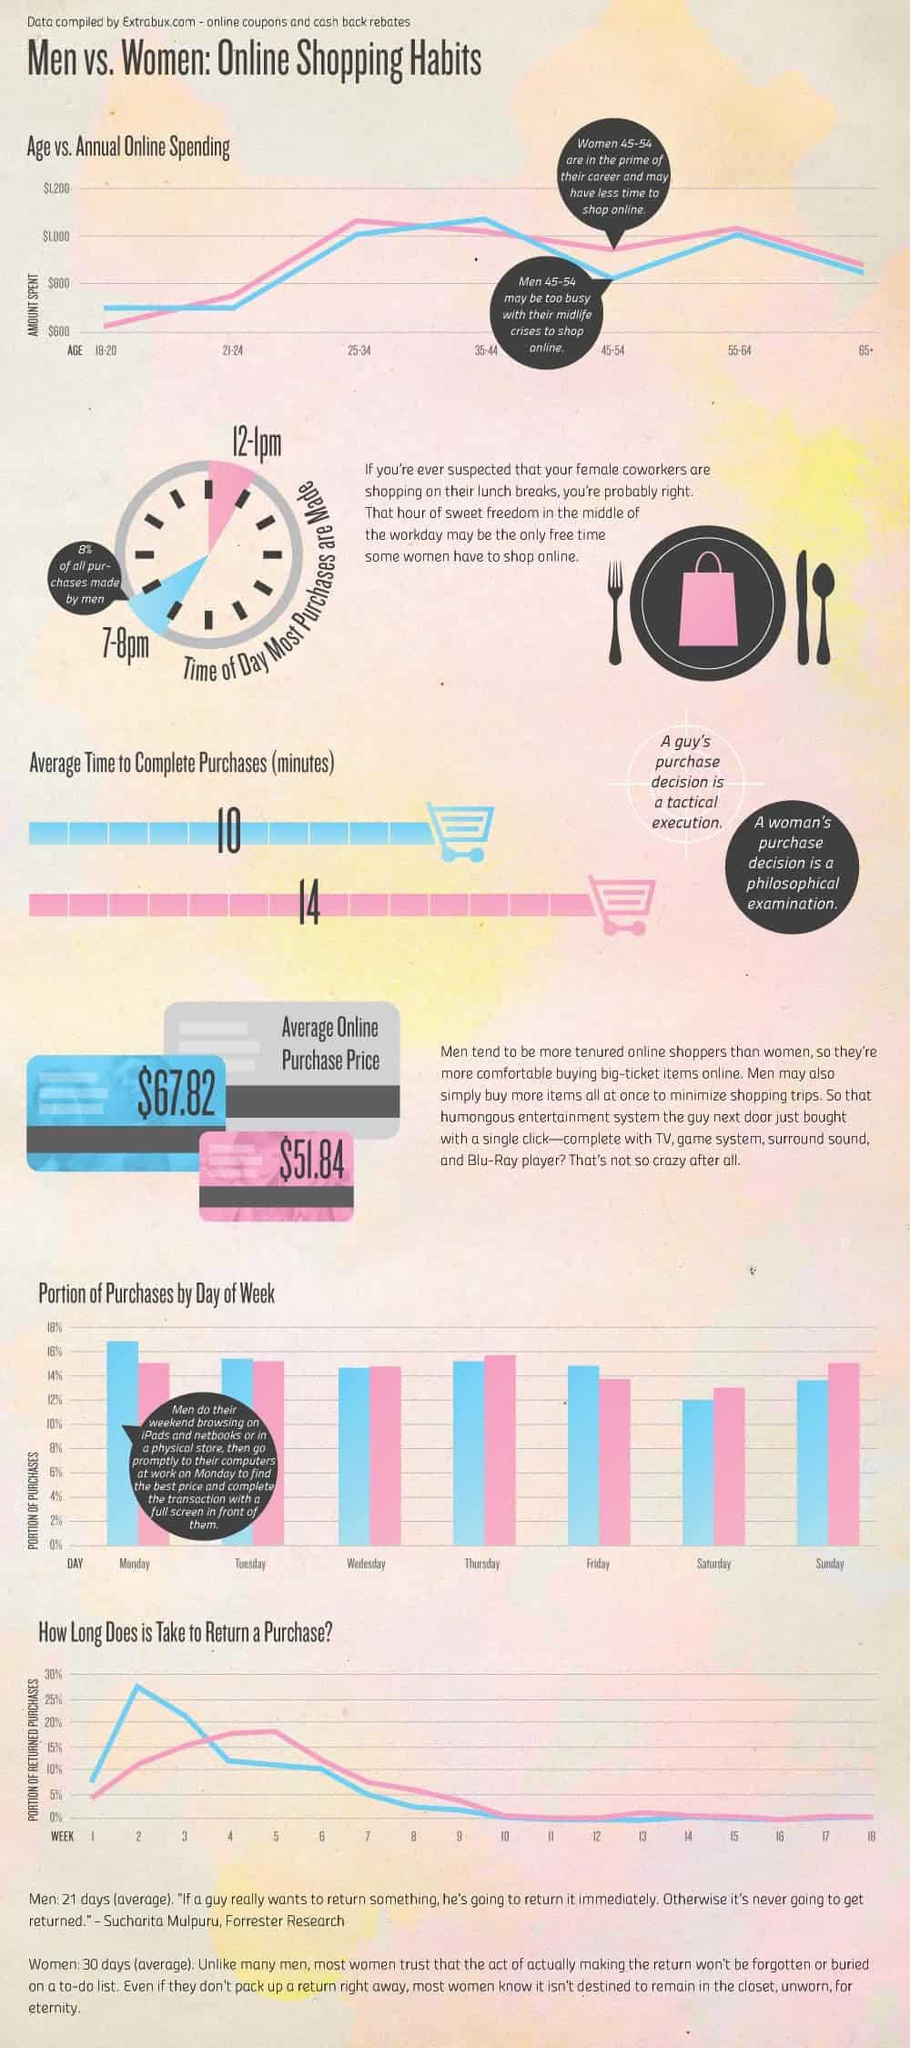Give some essential details in this illustration. According to data, men tend to make the most of their online purchases during the hours of 7-8 pm. Women typically make the majority of their online purchases during the 12-1 pm time frame of the day. The average time taken by women to complete online purchases is approximately 14 minutes. According to recent studies, the average time taken by men to complete online purchases is approximately 10 minutes. According to the given data, men aged 35-44 are the age group that spends the most on online shopping, with an annual average of over $1,000. 